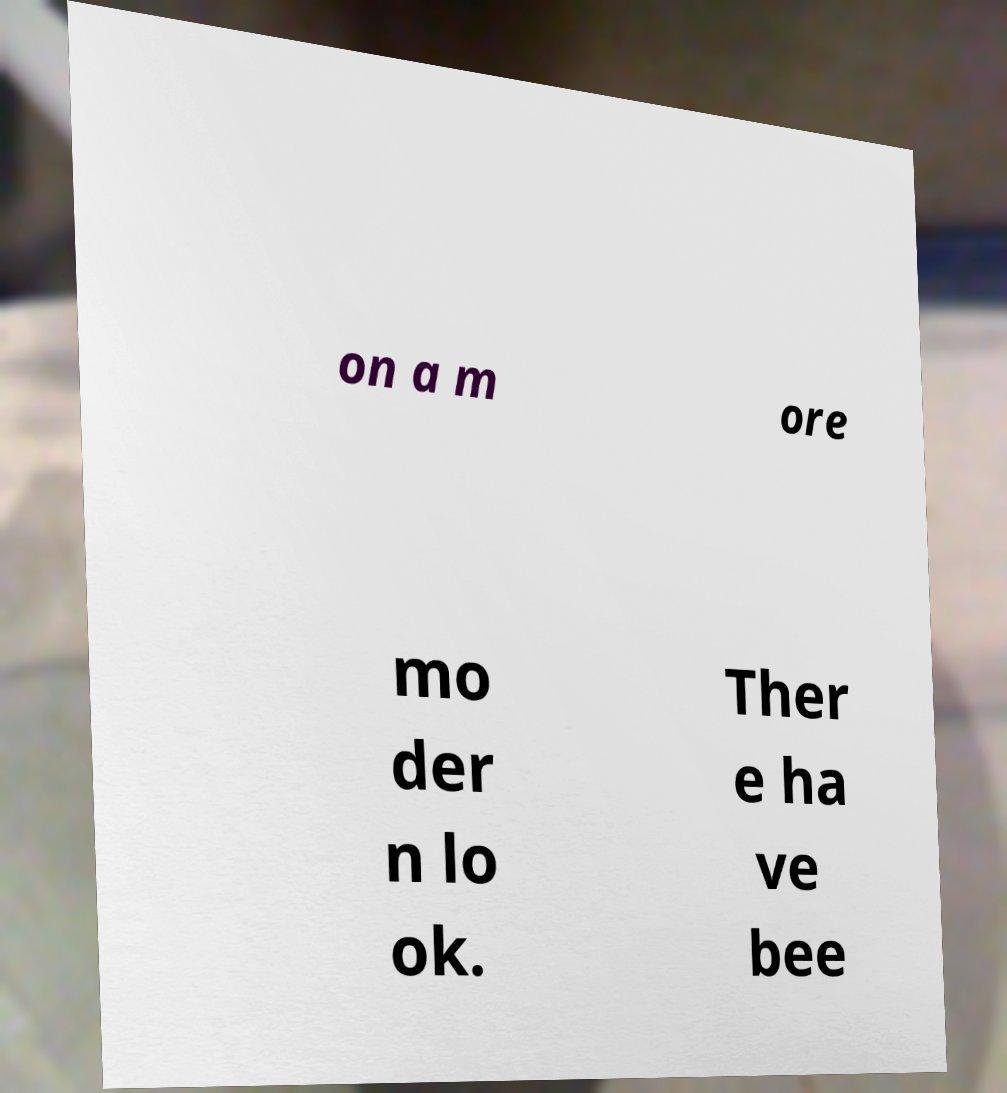I need the written content from this picture converted into text. Can you do that? on a m ore mo der n lo ok. Ther e ha ve bee 